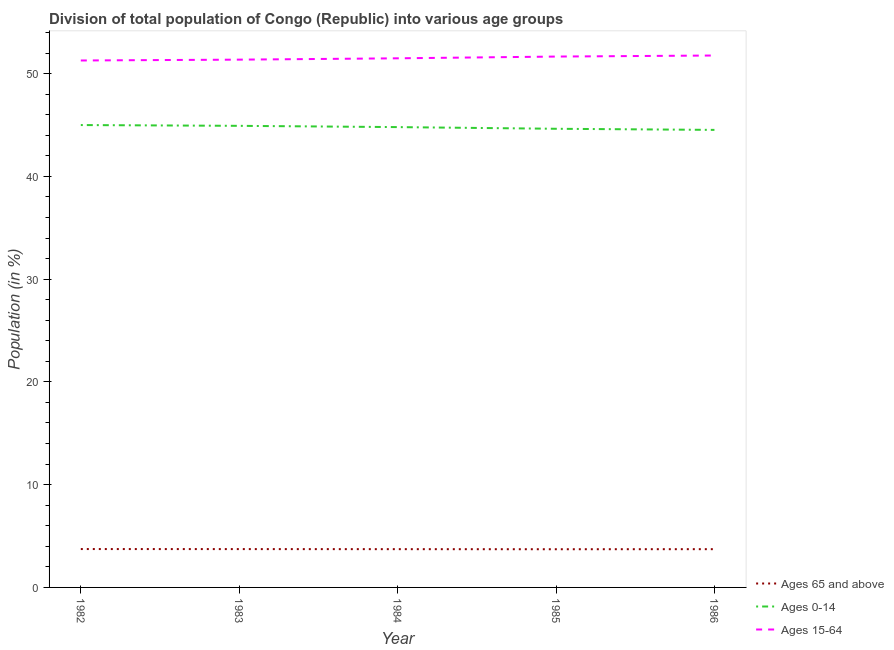How many different coloured lines are there?
Make the answer very short. 3. Does the line corresponding to percentage of population within the age-group 15-64 intersect with the line corresponding to percentage of population within the age-group of 65 and above?
Make the answer very short. No. Is the number of lines equal to the number of legend labels?
Make the answer very short. Yes. What is the percentage of population within the age-group of 65 and above in 1986?
Your response must be concise. 3.72. Across all years, what is the maximum percentage of population within the age-group of 65 and above?
Your answer should be very brief. 3.73. Across all years, what is the minimum percentage of population within the age-group of 65 and above?
Offer a terse response. 3.72. In which year was the percentage of population within the age-group of 65 and above maximum?
Ensure brevity in your answer.  1982. In which year was the percentage of population within the age-group of 65 and above minimum?
Ensure brevity in your answer.  1985. What is the total percentage of population within the age-group 15-64 in the graph?
Keep it short and to the point. 257.53. What is the difference between the percentage of population within the age-group 15-64 in 1985 and that in 1986?
Provide a succinct answer. -0.1. What is the difference between the percentage of population within the age-group 0-14 in 1983 and the percentage of population within the age-group of 65 and above in 1985?
Your answer should be very brief. 41.2. What is the average percentage of population within the age-group 15-64 per year?
Provide a succinct answer. 51.51. In the year 1983, what is the difference between the percentage of population within the age-group of 65 and above and percentage of population within the age-group 15-64?
Offer a very short reply. -47.63. In how many years, is the percentage of population within the age-group 0-14 greater than 34 %?
Provide a succinct answer. 5. What is the ratio of the percentage of population within the age-group of 65 and above in 1984 to that in 1986?
Make the answer very short. 1. Is the percentage of population within the age-group of 65 and above in 1982 less than that in 1983?
Provide a succinct answer. No. What is the difference between the highest and the second highest percentage of population within the age-group of 65 and above?
Offer a very short reply. 0. What is the difference between the highest and the lowest percentage of population within the age-group 15-64?
Your answer should be very brief. 0.48. Is it the case that in every year, the sum of the percentage of population within the age-group of 65 and above and percentage of population within the age-group 0-14 is greater than the percentage of population within the age-group 15-64?
Your answer should be very brief. No. Does the graph contain any zero values?
Your answer should be compact. No. Does the graph contain grids?
Ensure brevity in your answer.  No. Where does the legend appear in the graph?
Make the answer very short. Bottom right. What is the title of the graph?
Ensure brevity in your answer.  Division of total population of Congo (Republic) into various age groups
. Does "Methane" appear as one of the legend labels in the graph?
Keep it short and to the point. No. What is the label or title of the X-axis?
Provide a short and direct response. Year. What is the label or title of the Y-axis?
Offer a very short reply. Population (in %). What is the Population (in %) in Ages 65 and above in 1982?
Give a very brief answer. 3.73. What is the Population (in %) in Ages 0-14 in 1982?
Your response must be concise. 44.99. What is the Population (in %) of Ages 15-64 in 1982?
Offer a terse response. 51.27. What is the Population (in %) of Ages 65 and above in 1983?
Your answer should be very brief. 3.73. What is the Population (in %) in Ages 0-14 in 1983?
Your answer should be very brief. 44.91. What is the Population (in %) of Ages 15-64 in 1983?
Provide a succinct answer. 51.36. What is the Population (in %) in Ages 65 and above in 1984?
Make the answer very short. 3.72. What is the Population (in %) of Ages 0-14 in 1984?
Your response must be concise. 44.79. What is the Population (in %) in Ages 15-64 in 1984?
Provide a succinct answer. 51.49. What is the Population (in %) of Ages 65 and above in 1985?
Make the answer very short. 3.72. What is the Population (in %) in Ages 0-14 in 1985?
Provide a short and direct response. 44.63. What is the Population (in %) of Ages 15-64 in 1985?
Provide a short and direct response. 51.66. What is the Population (in %) in Ages 65 and above in 1986?
Offer a terse response. 3.72. What is the Population (in %) of Ages 0-14 in 1986?
Provide a succinct answer. 44.52. What is the Population (in %) in Ages 15-64 in 1986?
Make the answer very short. 51.76. Across all years, what is the maximum Population (in %) of Ages 65 and above?
Offer a terse response. 3.73. Across all years, what is the maximum Population (in %) of Ages 0-14?
Ensure brevity in your answer.  44.99. Across all years, what is the maximum Population (in %) of Ages 15-64?
Your answer should be compact. 51.76. Across all years, what is the minimum Population (in %) in Ages 65 and above?
Provide a short and direct response. 3.72. Across all years, what is the minimum Population (in %) of Ages 0-14?
Make the answer very short. 44.52. Across all years, what is the minimum Population (in %) of Ages 15-64?
Ensure brevity in your answer.  51.27. What is the total Population (in %) in Ages 65 and above in the graph?
Offer a very short reply. 18.63. What is the total Population (in %) of Ages 0-14 in the graph?
Keep it short and to the point. 223.85. What is the total Population (in %) in Ages 15-64 in the graph?
Offer a terse response. 257.53. What is the difference between the Population (in %) in Ages 65 and above in 1982 and that in 1983?
Make the answer very short. 0. What is the difference between the Population (in %) in Ages 0-14 in 1982 and that in 1983?
Ensure brevity in your answer.  0.08. What is the difference between the Population (in %) in Ages 15-64 in 1982 and that in 1983?
Your response must be concise. -0.08. What is the difference between the Population (in %) in Ages 65 and above in 1982 and that in 1984?
Your answer should be very brief. 0.01. What is the difference between the Population (in %) in Ages 0-14 in 1982 and that in 1984?
Ensure brevity in your answer.  0.2. What is the difference between the Population (in %) in Ages 15-64 in 1982 and that in 1984?
Offer a very short reply. -0.21. What is the difference between the Population (in %) of Ages 65 and above in 1982 and that in 1985?
Your response must be concise. 0.02. What is the difference between the Population (in %) of Ages 0-14 in 1982 and that in 1985?
Ensure brevity in your answer.  0.36. What is the difference between the Population (in %) of Ages 15-64 in 1982 and that in 1985?
Offer a very short reply. -0.38. What is the difference between the Population (in %) of Ages 65 and above in 1982 and that in 1986?
Ensure brevity in your answer.  0.01. What is the difference between the Population (in %) in Ages 0-14 in 1982 and that in 1986?
Ensure brevity in your answer.  0.47. What is the difference between the Population (in %) in Ages 15-64 in 1982 and that in 1986?
Keep it short and to the point. -0.48. What is the difference between the Population (in %) of Ages 65 and above in 1983 and that in 1984?
Your answer should be compact. 0.01. What is the difference between the Population (in %) of Ages 0-14 in 1983 and that in 1984?
Your answer should be compact. 0.12. What is the difference between the Population (in %) of Ages 15-64 in 1983 and that in 1984?
Your response must be concise. -0.13. What is the difference between the Population (in %) in Ages 65 and above in 1983 and that in 1985?
Keep it short and to the point. 0.01. What is the difference between the Population (in %) of Ages 0-14 in 1983 and that in 1985?
Provide a succinct answer. 0.29. What is the difference between the Population (in %) of Ages 15-64 in 1983 and that in 1985?
Your answer should be very brief. -0.3. What is the difference between the Population (in %) of Ages 65 and above in 1983 and that in 1986?
Provide a succinct answer. 0.01. What is the difference between the Population (in %) in Ages 0-14 in 1983 and that in 1986?
Your answer should be compact. 0.4. What is the difference between the Population (in %) in Ages 15-64 in 1983 and that in 1986?
Make the answer very short. -0.4. What is the difference between the Population (in %) in Ages 65 and above in 1984 and that in 1985?
Provide a succinct answer. 0.01. What is the difference between the Population (in %) of Ages 0-14 in 1984 and that in 1985?
Your answer should be compact. 0.16. What is the difference between the Population (in %) in Ages 15-64 in 1984 and that in 1985?
Your answer should be very brief. -0.17. What is the difference between the Population (in %) in Ages 65 and above in 1984 and that in 1986?
Provide a short and direct response. 0. What is the difference between the Population (in %) of Ages 0-14 in 1984 and that in 1986?
Keep it short and to the point. 0.27. What is the difference between the Population (in %) of Ages 15-64 in 1984 and that in 1986?
Keep it short and to the point. -0.27. What is the difference between the Population (in %) in Ages 65 and above in 1985 and that in 1986?
Offer a very short reply. -0.01. What is the difference between the Population (in %) of Ages 0-14 in 1985 and that in 1986?
Keep it short and to the point. 0.11. What is the difference between the Population (in %) of Ages 15-64 in 1985 and that in 1986?
Offer a terse response. -0.1. What is the difference between the Population (in %) in Ages 65 and above in 1982 and the Population (in %) in Ages 0-14 in 1983?
Give a very brief answer. -41.18. What is the difference between the Population (in %) in Ages 65 and above in 1982 and the Population (in %) in Ages 15-64 in 1983?
Keep it short and to the point. -47.62. What is the difference between the Population (in %) of Ages 0-14 in 1982 and the Population (in %) of Ages 15-64 in 1983?
Offer a very short reply. -6.36. What is the difference between the Population (in %) of Ages 65 and above in 1982 and the Population (in %) of Ages 0-14 in 1984?
Offer a very short reply. -41.06. What is the difference between the Population (in %) of Ages 65 and above in 1982 and the Population (in %) of Ages 15-64 in 1984?
Offer a very short reply. -47.75. What is the difference between the Population (in %) of Ages 0-14 in 1982 and the Population (in %) of Ages 15-64 in 1984?
Make the answer very short. -6.49. What is the difference between the Population (in %) of Ages 65 and above in 1982 and the Population (in %) of Ages 0-14 in 1985?
Your answer should be compact. -40.89. What is the difference between the Population (in %) of Ages 65 and above in 1982 and the Population (in %) of Ages 15-64 in 1985?
Ensure brevity in your answer.  -47.92. What is the difference between the Population (in %) in Ages 0-14 in 1982 and the Population (in %) in Ages 15-64 in 1985?
Your answer should be very brief. -6.66. What is the difference between the Population (in %) in Ages 65 and above in 1982 and the Population (in %) in Ages 0-14 in 1986?
Offer a terse response. -40.79. What is the difference between the Population (in %) in Ages 65 and above in 1982 and the Population (in %) in Ages 15-64 in 1986?
Your response must be concise. -48.02. What is the difference between the Population (in %) in Ages 0-14 in 1982 and the Population (in %) in Ages 15-64 in 1986?
Provide a short and direct response. -6.77. What is the difference between the Population (in %) in Ages 65 and above in 1983 and the Population (in %) in Ages 0-14 in 1984?
Offer a very short reply. -41.06. What is the difference between the Population (in %) in Ages 65 and above in 1983 and the Population (in %) in Ages 15-64 in 1984?
Give a very brief answer. -47.76. What is the difference between the Population (in %) in Ages 0-14 in 1983 and the Population (in %) in Ages 15-64 in 1984?
Offer a terse response. -6.57. What is the difference between the Population (in %) in Ages 65 and above in 1983 and the Population (in %) in Ages 0-14 in 1985?
Provide a succinct answer. -40.9. What is the difference between the Population (in %) in Ages 65 and above in 1983 and the Population (in %) in Ages 15-64 in 1985?
Ensure brevity in your answer.  -47.93. What is the difference between the Population (in %) of Ages 0-14 in 1983 and the Population (in %) of Ages 15-64 in 1985?
Provide a short and direct response. -6.74. What is the difference between the Population (in %) in Ages 65 and above in 1983 and the Population (in %) in Ages 0-14 in 1986?
Provide a succinct answer. -40.79. What is the difference between the Population (in %) of Ages 65 and above in 1983 and the Population (in %) of Ages 15-64 in 1986?
Provide a short and direct response. -48.03. What is the difference between the Population (in %) in Ages 0-14 in 1983 and the Population (in %) in Ages 15-64 in 1986?
Give a very brief answer. -6.84. What is the difference between the Population (in %) of Ages 65 and above in 1984 and the Population (in %) of Ages 0-14 in 1985?
Give a very brief answer. -40.91. What is the difference between the Population (in %) in Ages 65 and above in 1984 and the Population (in %) in Ages 15-64 in 1985?
Provide a short and direct response. -47.93. What is the difference between the Population (in %) of Ages 0-14 in 1984 and the Population (in %) of Ages 15-64 in 1985?
Provide a short and direct response. -6.86. What is the difference between the Population (in %) in Ages 65 and above in 1984 and the Population (in %) in Ages 0-14 in 1986?
Offer a terse response. -40.8. What is the difference between the Population (in %) of Ages 65 and above in 1984 and the Population (in %) of Ages 15-64 in 1986?
Your answer should be compact. -48.03. What is the difference between the Population (in %) of Ages 0-14 in 1984 and the Population (in %) of Ages 15-64 in 1986?
Offer a very short reply. -6.97. What is the difference between the Population (in %) in Ages 65 and above in 1985 and the Population (in %) in Ages 0-14 in 1986?
Give a very brief answer. -40.8. What is the difference between the Population (in %) of Ages 65 and above in 1985 and the Population (in %) of Ages 15-64 in 1986?
Provide a short and direct response. -48.04. What is the difference between the Population (in %) of Ages 0-14 in 1985 and the Population (in %) of Ages 15-64 in 1986?
Your answer should be compact. -7.13. What is the average Population (in %) of Ages 65 and above per year?
Keep it short and to the point. 3.73. What is the average Population (in %) in Ages 0-14 per year?
Your answer should be compact. 44.77. What is the average Population (in %) in Ages 15-64 per year?
Keep it short and to the point. 51.51. In the year 1982, what is the difference between the Population (in %) of Ages 65 and above and Population (in %) of Ages 0-14?
Your answer should be very brief. -41.26. In the year 1982, what is the difference between the Population (in %) of Ages 65 and above and Population (in %) of Ages 15-64?
Offer a very short reply. -47.54. In the year 1982, what is the difference between the Population (in %) in Ages 0-14 and Population (in %) in Ages 15-64?
Your answer should be compact. -6.28. In the year 1983, what is the difference between the Population (in %) of Ages 65 and above and Population (in %) of Ages 0-14?
Make the answer very short. -41.18. In the year 1983, what is the difference between the Population (in %) of Ages 65 and above and Population (in %) of Ages 15-64?
Give a very brief answer. -47.63. In the year 1983, what is the difference between the Population (in %) of Ages 0-14 and Population (in %) of Ages 15-64?
Offer a very short reply. -6.44. In the year 1984, what is the difference between the Population (in %) in Ages 65 and above and Population (in %) in Ages 0-14?
Ensure brevity in your answer.  -41.07. In the year 1984, what is the difference between the Population (in %) of Ages 65 and above and Population (in %) of Ages 15-64?
Keep it short and to the point. -47.76. In the year 1984, what is the difference between the Population (in %) in Ages 0-14 and Population (in %) in Ages 15-64?
Give a very brief answer. -6.69. In the year 1985, what is the difference between the Population (in %) in Ages 65 and above and Population (in %) in Ages 0-14?
Provide a succinct answer. -40.91. In the year 1985, what is the difference between the Population (in %) of Ages 65 and above and Population (in %) of Ages 15-64?
Offer a very short reply. -47.94. In the year 1985, what is the difference between the Population (in %) of Ages 0-14 and Population (in %) of Ages 15-64?
Give a very brief answer. -7.03. In the year 1986, what is the difference between the Population (in %) of Ages 65 and above and Population (in %) of Ages 0-14?
Your response must be concise. -40.8. In the year 1986, what is the difference between the Population (in %) of Ages 65 and above and Population (in %) of Ages 15-64?
Your answer should be compact. -48.03. In the year 1986, what is the difference between the Population (in %) of Ages 0-14 and Population (in %) of Ages 15-64?
Your response must be concise. -7.24. What is the ratio of the Population (in %) of Ages 65 and above in 1982 to that in 1983?
Offer a very short reply. 1. What is the ratio of the Population (in %) in Ages 15-64 in 1982 to that in 1983?
Your answer should be very brief. 1. What is the ratio of the Population (in %) in Ages 65 and above in 1982 to that in 1985?
Keep it short and to the point. 1. What is the ratio of the Population (in %) in Ages 0-14 in 1982 to that in 1985?
Your answer should be compact. 1.01. What is the ratio of the Population (in %) in Ages 15-64 in 1982 to that in 1985?
Give a very brief answer. 0.99. What is the ratio of the Population (in %) in Ages 65 and above in 1982 to that in 1986?
Your answer should be very brief. 1. What is the ratio of the Population (in %) of Ages 0-14 in 1982 to that in 1986?
Provide a short and direct response. 1.01. What is the ratio of the Population (in %) of Ages 15-64 in 1983 to that in 1984?
Give a very brief answer. 1. What is the ratio of the Population (in %) of Ages 0-14 in 1983 to that in 1985?
Offer a very short reply. 1.01. What is the ratio of the Population (in %) in Ages 0-14 in 1983 to that in 1986?
Provide a short and direct response. 1.01. What is the ratio of the Population (in %) in Ages 15-64 in 1983 to that in 1986?
Ensure brevity in your answer.  0.99. What is the ratio of the Population (in %) in Ages 65 and above in 1984 to that in 1985?
Offer a very short reply. 1. What is the ratio of the Population (in %) of Ages 0-14 in 1984 to that in 1985?
Keep it short and to the point. 1. What is the ratio of the Population (in %) in Ages 65 and above in 1984 to that in 1986?
Offer a terse response. 1. What is the ratio of the Population (in %) of Ages 15-64 in 1984 to that in 1986?
Offer a very short reply. 0.99. What is the ratio of the Population (in %) in Ages 0-14 in 1985 to that in 1986?
Provide a succinct answer. 1. What is the difference between the highest and the second highest Population (in %) of Ages 65 and above?
Offer a very short reply. 0. What is the difference between the highest and the second highest Population (in %) in Ages 0-14?
Offer a very short reply. 0.08. What is the difference between the highest and the second highest Population (in %) of Ages 15-64?
Your response must be concise. 0.1. What is the difference between the highest and the lowest Population (in %) in Ages 65 and above?
Ensure brevity in your answer.  0.02. What is the difference between the highest and the lowest Population (in %) in Ages 0-14?
Provide a succinct answer. 0.47. What is the difference between the highest and the lowest Population (in %) in Ages 15-64?
Keep it short and to the point. 0.48. 